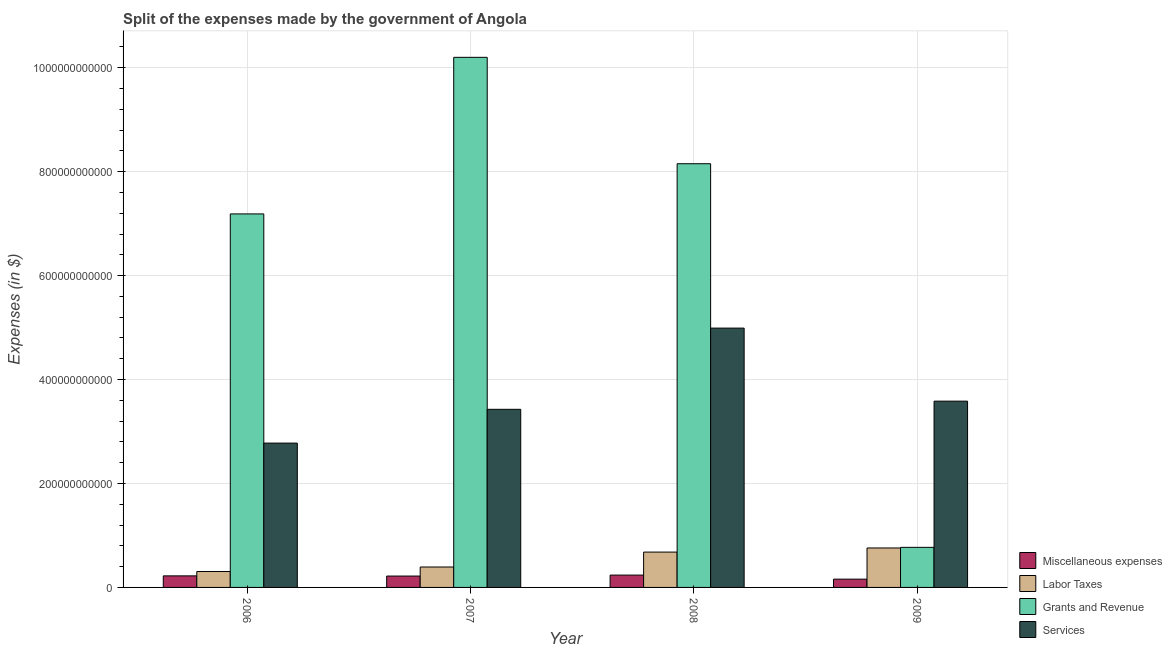How many different coloured bars are there?
Give a very brief answer. 4. How many bars are there on the 3rd tick from the right?
Your answer should be very brief. 4. What is the label of the 1st group of bars from the left?
Offer a terse response. 2006. What is the amount spent on grants and revenue in 2006?
Your answer should be compact. 7.19e+11. Across all years, what is the maximum amount spent on grants and revenue?
Your answer should be compact. 1.02e+12. Across all years, what is the minimum amount spent on grants and revenue?
Give a very brief answer. 7.71e+1. In which year was the amount spent on miscellaneous expenses maximum?
Ensure brevity in your answer.  2008. In which year was the amount spent on services minimum?
Keep it short and to the point. 2006. What is the total amount spent on grants and revenue in the graph?
Your answer should be compact. 2.63e+12. What is the difference between the amount spent on labor taxes in 2008 and that in 2009?
Your response must be concise. -7.90e+09. What is the difference between the amount spent on labor taxes in 2009 and the amount spent on miscellaneous expenses in 2007?
Provide a succinct answer. 3.66e+1. What is the average amount spent on grants and revenue per year?
Offer a very short reply. 6.58e+11. In how many years, is the amount spent on labor taxes greater than 640000000000 $?
Keep it short and to the point. 0. What is the ratio of the amount spent on grants and revenue in 2008 to that in 2009?
Make the answer very short. 10.57. Is the difference between the amount spent on services in 2007 and 2009 greater than the difference between the amount spent on grants and revenue in 2007 and 2009?
Make the answer very short. No. What is the difference between the highest and the second highest amount spent on labor taxes?
Your answer should be very brief. 7.90e+09. What is the difference between the highest and the lowest amount spent on labor taxes?
Give a very brief answer. 4.53e+1. Is the sum of the amount spent on services in 2008 and 2009 greater than the maximum amount spent on labor taxes across all years?
Give a very brief answer. Yes. Is it the case that in every year, the sum of the amount spent on miscellaneous expenses and amount spent on services is greater than the sum of amount spent on grants and revenue and amount spent on labor taxes?
Your answer should be compact. No. What does the 1st bar from the left in 2007 represents?
Your response must be concise. Miscellaneous expenses. What does the 1st bar from the right in 2009 represents?
Your answer should be compact. Services. Is it the case that in every year, the sum of the amount spent on miscellaneous expenses and amount spent on labor taxes is greater than the amount spent on grants and revenue?
Your answer should be very brief. No. How many bars are there?
Your response must be concise. 16. Are all the bars in the graph horizontal?
Provide a succinct answer. No. What is the difference between two consecutive major ticks on the Y-axis?
Your answer should be very brief. 2.00e+11. Does the graph contain any zero values?
Offer a terse response. No. Does the graph contain grids?
Make the answer very short. Yes. How many legend labels are there?
Provide a succinct answer. 4. How are the legend labels stacked?
Your answer should be compact. Vertical. What is the title of the graph?
Your answer should be compact. Split of the expenses made by the government of Angola. What is the label or title of the X-axis?
Keep it short and to the point. Year. What is the label or title of the Y-axis?
Offer a very short reply. Expenses (in $). What is the Expenses (in $) of Miscellaneous expenses in 2006?
Your response must be concise. 2.22e+1. What is the Expenses (in $) of Labor Taxes in 2006?
Your answer should be compact. 3.06e+1. What is the Expenses (in $) of Grants and Revenue in 2006?
Offer a very short reply. 7.19e+11. What is the Expenses (in $) in Services in 2006?
Provide a succinct answer. 2.78e+11. What is the Expenses (in $) of Miscellaneous expenses in 2007?
Keep it short and to the point. 2.19e+1. What is the Expenses (in $) of Labor Taxes in 2007?
Provide a short and direct response. 3.93e+1. What is the Expenses (in $) of Grants and Revenue in 2007?
Your response must be concise. 1.02e+12. What is the Expenses (in $) in Services in 2007?
Provide a succinct answer. 3.43e+11. What is the Expenses (in $) in Miscellaneous expenses in 2008?
Your response must be concise. 2.38e+1. What is the Expenses (in $) in Labor Taxes in 2008?
Ensure brevity in your answer.  6.80e+1. What is the Expenses (in $) of Grants and Revenue in 2008?
Your answer should be very brief. 8.15e+11. What is the Expenses (in $) of Services in 2008?
Keep it short and to the point. 4.99e+11. What is the Expenses (in $) in Miscellaneous expenses in 2009?
Give a very brief answer. 1.59e+1. What is the Expenses (in $) of Labor Taxes in 2009?
Offer a very short reply. 7.59e+1. What is the Expenses (in $) of Grants and Revenue in 2009?
Keep it short and to the point. 7.71e+1. What is the Expenses (in $) in Services in 2009?
Your response must be concise. 3.58e+11. Across all years, what is the maximum Expenses (in $) in Miscellaneous expenses?
Provide a succinct answer. 2.38e+1. Across all years, what is the maximum Expenses (in $) in Labor Taxes?
Make the answer very short. 7.59e+1. Across all years, what is the maximum Expenses (in $) in Grants and Revenue?
Keep it short and to the point. 1.02e+12. Across all years, what is the maximum Expenses (in $) of Services?
Offer a terse response. 4.99e+11. Across all years, what is the minimum Expenses (in $) in Miscellaneous expenses?
Provide a short and direct response. 1.59e+1. Across all years, what is the minimum Expenses (in $) of Labor Taxes?
Give a very brief answer. 3.06e+1. Across all years, what is the minimum Expenses (in $) in Grants and Revenue?
Offer a very short reply. 7.71e+1. Across all years, what is the minimum Expenses (in $) of Services?
Provide a succinct answer. 2.78e+11. What is the total Expenses (in $) of Miscellaneous expenses in the graph?
Give a very brief answer. 8.38e+1. What is the total Expenses (in $) of Labor Taxes in the graph?
Ensure brevity in your answer.  2.14e+11. What is the total Expenses (in $) of Grants and Revenue in the graph?
Your answer should be compact. 2.63e+12. What is the total Expenses (in $) in Services in the graph?
Your response must be concise. 1.48e+12. What is the difference between the Expenses (in $) in Miscellaneous expenses in 2006 and that in 2007?
Keep it short and to the point. 3.67e+08. What is the difference between the Expenses (in $) of Labor Taxes in 2006 and that in 2007?
Provide a short and direct response. -8.70e+09. What is the difference between the Expenses (in $) in Grants and Revenue in 2006 and that in 2007?
Ensure brevity in your answer.  -3.01e+11. What is the difference between the Expenses (in $) of Services in 2006 and that in 2007?
Give a very brief answer. -6.50e+1. What is the difference between the Expenses (in $) in Miscellaneous expenses in 2006 and that in 2008?
Your response must be concise. -1.52e+09. What is the difference between the Expenses (in $) in Labor Taxes in 2006 and that in 2008?
Ensure brevity in your answer.  -3.74e+1. What is the difference between the Expenses (in $) in Grants and Revenue in 2006 and that in 2008?
Make the answer very short. -9.66e+1. What is the difference between the Expenses (in $) in Services in 2006 and that in 2008?
Your answer should be compact. -2.21e+11. What is the difference between the Expenses (in $) in Miscellaneous expenses in 2006 and that in 2009?
Your answer should be compact. 6.31e+09. What is the difference between the Expenses (in $) of Labor Taxes in 2006 and that in 2009?
Keep it short and to the point. -4.53e+1. What is the difference between the Expenses (in $) of Grants and Revenue in 2006 and that in 2009?
Keep it short and to the point. 6.42e+11. What is the difference between the Expenses (in $) of Services in 2006 and that in 2009?
Provide a succinct answer. -8.07e+1. What is the difference between the Expenses (in $) in Miscellaneous expenses in 2007 and that in 2008?
Your answer should be very brief. -1.88e+09. What is the difference between the Expenses (in $) in Labor Taxes in 2007 and that in 2008?
Make the answer very short. -2.87e+1. What is the difference between the Expenses (in $) in Grants and Revenue in 2007 and that in 2008?
Keep it short and to the point. 2.05e+11. What is the difference between the Expenses (in $) of Services in 2007 and that in 2008?
Make the answer very short. -1.56e+11. What is the difference between the Expenses (in $) in Miscellaneous expenses in 2007 and that in 2009?
Ensure brevity in your answer.  5.95e+09. What is the difference between the Expenses (in $) of Labor Taxes in 2007 and that in 2009?
Give a very brief answer. -3.66e+1. What is the difference between the Expenses (in $) in Grants and Revenue in 2007 and that in 2009?
Give a very brief answer. 9.43e+11. What is the difference between the Expenses (in $) of Services in 2007 and that in 2009?
Provide a short and direct response. -1.57e+1. What is the difference between the Expenses (in $) in Miscellaneous expenses in 2008 and that in 2009?
Your answer should be very brief. 7.83e+09. What is the difference between the Expenses (in $) of Labor Taxes in 2008 and that in 2009?
Offer a terse response. -7.90e+09. What is the difference between the Expenses (in $) of Grants and Revenue in 2008 and that in 2009?
Your answer should be compact. 7.38e+11. What is the difference between the Expenses (in $) of Services in 2008 and that in 2009?
Make the answer very short. 1.41e+11. What is the difference between the Expenses (in $) of Miscellaneous expenses in 2006 and the Expenses (in $) of Labor Taxes in 2007?
Ensure brevity in your answer.  -1.71e+1. What is the difference between the Expenses (in $) of Miscellaneous expenses in 2006 and the Expenses (in $) of Grants and Revenue in 2007?
Your answer should be compact. -9.98e+11. What is the difference between the Expenses (in $) in Miscellaneous expenses in 2006 and the Expenses (in $) in Services in 2007?
Offer a very short reply. -3.21e+11. What is the difference between the Expenses (in $) of Labor Taxes in 2006 and the Expenses (in $) of Grants and Revenue in 2007?
Ensure brevity in your answer.  -9.89e+11. What is the difference between the Expenses (in $) of Labor Taxes in 2006 and the Expenses (in $) of Services in 2007?
Your response must be concise. -3.12e+11. What is the difference between the Expenses (in $) of Grants and Revenue in 2006 and the Expenses (in $) of Services in 2007?
Provide a succinct answer. 3.76e+11. What is the difference between the Expenses (in $) in Miscellaneous expenses in 2006 and the Expenses (in $) in Labor Taxes in 2008?
Offer a very short reply. -4.58e+1. What is the difference between the Expenses (in $) of Miscellaneous expenses in 2006 and the Expenses (in $) of Grants and Revenue in 2008?
Your answer should be very brief. -7.93e+11. What is the difference between the Expenses (in $) in Miscellaneous expenses in 2006 and the Expenses (in $) in Services in 2008?
Offer a very short reply. -4.77e+11. What is the difference between the Expenses (in $) of Labor Taxes in 2006 and the Expenses (in $) of Grants and Revenue in 2008?
Keep it short and to the point. -7.85e+11. What is the difference between the Expenses (in $) of Labor Taxes in 2006 and the Expenses (in $) of Services in 2008?
Your response must be concise. -4.68e+11. What is the difference between the Expenses (in $) in Grants and Revenue in 2006 and the Expenses (in $) in Services in 2008?
Your response must be concise. 2.20e+11. What is the difference between the Expenses (in $) in Miscellaneous expenses in 2006 and the Expenses (in $) in Labor Taxes in 2009?
Make the answer very short. -5.37e+1. What is the difference between the Expenses (in $) in Miscellaneous expenses in 2006 and the Expenses (in $) in Grants and Revenue in 2009?
Offer a terse response. -5.49e+1. What is the difference between the Expenses (in $) of Miscellaneous expenses in 2006 and the Expenses (in $) of Services in 2009?
Keep it short and to the point. -3.36e+11. What is the difference between the Expenses (in $) in Labor Taxes in 2006 and the Expenses (in $) in Grants and Revenue in 2009?
Your answer should be very brief. -4.65e+1. What is the difference between the Expenses (in $) of Labor Taxes in 2006 and the Expenses (in $) of Services in 2009?
Give a very brief answer. -3.28e+11. What is the difference between the Expenses (in $) of Grants and Revenue in 2006 and the Expenses (in $) of Services in 2009?
Keep it short and to the point. 3.60e+11. What is the difference between the Expenses (in $) in Miscellaneous expenses in 2007 and the Expenses (in $) in Labor Taxes in 2008?
Offer a terse response. -4.61e+1. What is the difference between the Expenses (in $) in Miscellaneous expenses in 2007 and the Expenses (in $) in Grants and Revenue in 2008?
Provide a short and direct response. -7.93e+11. What is the difference between the Expenses (in $) of Miscellaneous expenses in 2007 and the Expenses (in $) of Services in 2008?
Offer a very short reply. -4.77e+11. What is the difference between the Expenses (in $) of Labor Taxes in 2007 and the Expenses (in $) of Grants and Revenue in 2008?
Your answer should be very brief. -7.76e+11. What is the difference between the Expenses (in $) of Labor Taxes in 2007 and the Expenses (in $) of Services in 2008?
Make the answer very short. -4.60e+11. What is the difference between the Expenses (in $) of Grants and Revenue in 2007 and the Expenses (in $) of Services in 2008?
Make the answer very short. 5.21e+11. What is the difference between the Expenses (in $) in Miscellaneous expenses in 2007 and the Expenses (in $) in Labor Taxes in 2009?
Provide a succinct answer. -5.40e+1. What is the difference between the Expenses (in $) in Miscellaneous expenses in 2007 and the Expenses (in $) in Grants and Revenue in 2009?
Ensure brevity in your answer.  -5.53e+1. What is the difference between the Expenses (in $) in Miscellaneous expenses in 2007 and the Expenses (in $) in Services in 2009?
Offer a very short reply. -3.37e+11. What is the difference between the Expenses (in $) in Labor Taxes in 2007 and the Expenses (in $) in Grants and Revenue in 2009?
Offer a terse response. -3.78e+1. What is the difference between the Expenses (in $) in Labor Taxes in 2007 and the Expenses (in $) in Services in 2009?
Provide a short and direct response. -3.19e+11. What is the difference between the Expenses (in $) in Grants and Revenue in 2007 and the Expenses (in $) in Services in 2009?
Give a very brief answer. 6.62e+11. What is the difference between the Expenses (in $) in Miscellaneous expenses in 2008 and the Expenses (in $) in Labor Taxes in 2009?
Ensure brevity in your answer.  -5.22e+1. What is the difference between the Expenses (in $) in Miscellaneous expenses in 2008 and the Expenses (in $) in Grants and Revenue in 2009?
Make the answer very short. -5.34e+1. What is the difference between the Expenses (in $) in Miscellaneous expenses in 2008 and the Expenses (in $) in Services in 2009?
Your answer should be very brief. -3.35e+11. What is the difference between the Expenses (in $) in Labor Taxes in 2008 and the Expenses (in $) in Grants and Revenue in 2009?
Your answer should be very brief. -9.12e+09. What is the difference between the Expenses (in $) in Labor Taxes in 2008 and the Expenses (in $) in Services in 2009?
Offer a terse response. -2.90e+11. What is the difference between the Expenses (in $) of Grants and Revenue in 2008 and the Expenses (in $) of Services in 2009?
Make the answer very short. 4.57e+11. What is the average Expenses (in $) of Miscellaneous expenses per year?
Offer a terse response. 2.09e+1. What is the average Expenses (in $) in Labor Taxes per year?
Your response must be concise. 5.35e+1. What is the average Expenses (in $) in Grants and Revenue per year?
Your answer should be compact. 6.58e+11. What is the average Expenses (in $) in Services per year?
Provide a succinct answer. 3.69e+11. In the year 2006, what is the difference between the Expenses (in $) of Miscellaneous expenses and Expenses (in $) of Labor Taxes?
Make the answer very short. -8.36e+09. In the year 2006, what is the difference between the Expenses (in $) in Miscellaneous expenses and Expenses (in $) in Grants and Revenue?
Ensure brevity in your answer.  -6.97e+11. In the year 2006, what is the difference between the Expenses (in $) of Miscellaneous expenses and Expenses (in $) of Services?
Keep it short and to the point. -2.55e+11. In the year 2006, what is the difference between the Expenses (in $) in Labor Taxes and Expenses (in $) in Grants and Revenue?
Ensure brevity in your answer.  -6.88e+11. In the year 2006, what is the difference between the Expenses (in $) of Labor Taxes and Expenses (in $) of Services?
Your answer should be very brief. -2.47e+11. In the year 2006, what is the difference between the Expenses (in $) of Grants and Revenue and Expenses (in $) of Services?
Provide a short and direct response. 4.41e+11. In the year 2007, what is the difference between the Expenses (in $) in Miscellaneous expenses and Expenses (in $) in Labor Taxes?
Keep it short and to the point. -1.74e+1. In the year 2007, what is the difference between the Expenses (in $) in Miscellaneous expenses and Expenses (in $) in Grants and Revenue?
Keep it short and to the point. -9.98e+11. In the year 2007, what is the difference between the Expenses (in $) of Miscellaneous expenses and Expenses (in $) of Services?
Keep it short and to the point. -3.21e+11. In the year 2007, what is the difference between the Expenses (in $) of Labor Taxes and Expenses (in $) of Grants and Revenue?
Your answer should be compact. -9.81e+11. In the year 2007, what is the difference between the Expenses (in $) of Labor Taxes and Expenses (in $) of Services?
Your answer should be very brief. -3.03e+11. In the year 2007, what is the difference between the Expenses (in $) in Grants and Revenue and Expenses (in $) in Services?
Provide a succinct answer. 6.77e+11. In the year 2008, what is the difference between the Expenses (in $) of Miscellaneous expenses and Expenses (in $) of Labor Taxes?
Ensure brevity in your answer.  -4.43e+1. In the year 2008, what is the difference between the Expenses (in $) in Miscellaneous expenses and Expenses (in $) in Grants and Revenue?
Keep it short and to the point. -7.92e+11. In the year 2008, what is the difference between the Expenses (in $) of Miscellaneous expenses and Expenses (in $) of Services?
Ensure brevity in your answer.  -4.75e+11. In the year 2008, what is the difference between the Expenses (in $) in Labor Taxes and Expenses (in $) in Grants and Revenue?
Offer a very short reply. -7.47e+11. In the year 2008, what is the difference between the Expenses (in $) of Labor Taxes and Expenses (in $) of Services?
Your answer should be very brief. -4.31e+11. In the year 2008, what is the difference between the Expenses (in $) in Grants and Revenue and Expenses (in $) in Services?
Keep it short and to the point. 3.16e+11. In the year 2009, what is the difference between the Expenses (in $) of Miscellaneous expenses and Expenses (in $) of Labor Taxes?
Offer a very short reply. -6.00e+1. In the year 2009, what is the difference between the Expenses (in $) in Miscellaneous expenses and Expenses (in $) in Grants and Revenue?
Give a very brief answer. -6.12e+1. In the year 2009, what is the difference between the Expenses (in $) of Miscellaneous expenses and Expenses (in $) of Services?
Ensure brevity in your answer.  -3.43e+11. In the year 2009, what is the difference between the Expenses (in $) in Labor Taxes and Expenses (in $) in Grants and Revenue?
Make the answer very short. -1.21e+09. In the year 2009, what is the difference between the Expenses (in $) of Labor Taxes and Expenses (in $) of Services?
Your answer should be very brief. -2.83e+11. In the year 2009, what is the difference between the Expenses (in $) of Grants and Revenue and Expenses (in $) of Services?
Offer a very short reply. -2.81e+11. What is the ratio of the Expenses (in $) in Miscellaneous expenses in 2006 to that in 2007?
Provide a short and direct response. 1.02. What is the ratio of the Expenses (in $) of Labor Taxes in 2006 to that in 2007?
Ensure brevity in your answer.  0.78. What is the ratio of the Expenses (in $) of Grants and Revenue in 2006 to that in 2007?
Provide a succinct answer. 0.7. What is the ratio of the Expenses (in $) of Services in 2006 to that in 2007?
Give a very brief answer. 0.81. What is the ratio of the Expenses (in $) of Miscellaneous expenses in 2006 to that in 2008?
Give a very brief answer. 0.94. What is the ratio of the Expenses (in $) in Labor Taxes in 2006 to that in 2008?
Make the answer very short. 0.45. What is the ratio of the Expenses (in $) in Grants and Revenue in 2006 to that in 2008?
Give a very brief answer. 0.88. What is the ratio of the Expenses (in $) in Services in 2006 to that in 2008?
Provide a succinct answer. 0.56. What is the ratio of the Expenses (in $) in Miscellaneous expenses in 2006 to that in 2009?
Your answer should be very brief. 1.4. What is the ratio of the Expenses (in $) in Labor Taxes in 2006 to that in 2009?
Keep it short and to the point. 0.4. What is the ratio of the Expenses (in $) in Grants and Revenue in 2006 to that in 2009?
Provide a short and direct response. 9.32. What is the ratio of the Expenses (in $) in Services in 2006 to that in 2009?
Keep it short and to the point. 0.77. What is the ratio of the Expenses (in $) of Miscellaneous expenses in 2007 to that in 2008?
Your response must be concise. 0.92. What is the ratio of the Expenses (in $) of Labor Taxes in 2007 to that in 2008?
Keep it short and to the point. 0.58. What is the ratio of the Expenses (in $) of Grants and Revenue in 2007 to that in 2008?
Your answer should be very brief. 1.25. What is the ratio of the Expenses (in $) in Services in 2007 to that in 2008?
Your answer should be compact. 0.69. What is the ratio of the Expenses (in $) in Miscellaneous expenses in 2007 to that in 2009?
Your answer should be very brief. 1.37. What is the ratio of the Expenses (in $) in Labor Taxes in 2007 to that in 2009?
Ensure brevity in your answer.  0.52. What is the ratio of the Expenses (in $) of Grants and Revenue in 2007 to that in 2009?
Ensure brevity in your answer.  13.23. What is the ratio of the Expenses (in $) of Services in 2007 to that in 2009?
Provide a short and direct response. 0.96. What is the ratio of the Expenses (in $) in Miscellaneous expenses in 2008 to that in 2009?
Provide a short and direct response. 1.49. What is the ratio of the Expenses (in $) of Labor Taxes in 2008 to that in 2009?
Give a very brief answer. 0.9. What is the ratio of the Expenses (in $) in Grants and Revenue in 2008 to that in 2009?
Ensure brevity in your answer.  10.57. What is the ratio of the Expenses (in $) of Services in 2008 to that in 2009?
Provide a short and direct response. 1.39. What is the difference between the highest and the second highest Expenses (in $) of Miscellaneous expenses?
Your answer should be compact. 1.52e+09. What is the difference between the highest and the second highest Expenses (in $) of Labor Taxes?
Offer a very short reply. 7.90e+09. What is the difference between the highest and the second highest Expenses (in $) of Grants and Revenue?
Your answer should be compact. 2.05e+11. What is the difference between the highest and the second highest Expenses (in $) of Services?
Your answer should be very brief. 1.41e+11. What is the difference between the highest and the lowest Expenses (in $) of Miscellaneous expenses?
Ensure brevity in your answer.  7.83e+09. What is the difference between the highest and the lowest Expenses (in $) of Labor Taxes?
Offer a very short reply. 4.53e+1. What is the difference between the highest and the lowest Expenses (in $) in Grants and Revenue?
Ensure brevity in your answer.  9.43e+11. What is the difference between the highest and the lowest Expenses (in $) of Services?
Your answer should be very brief. 2.21e+11. 